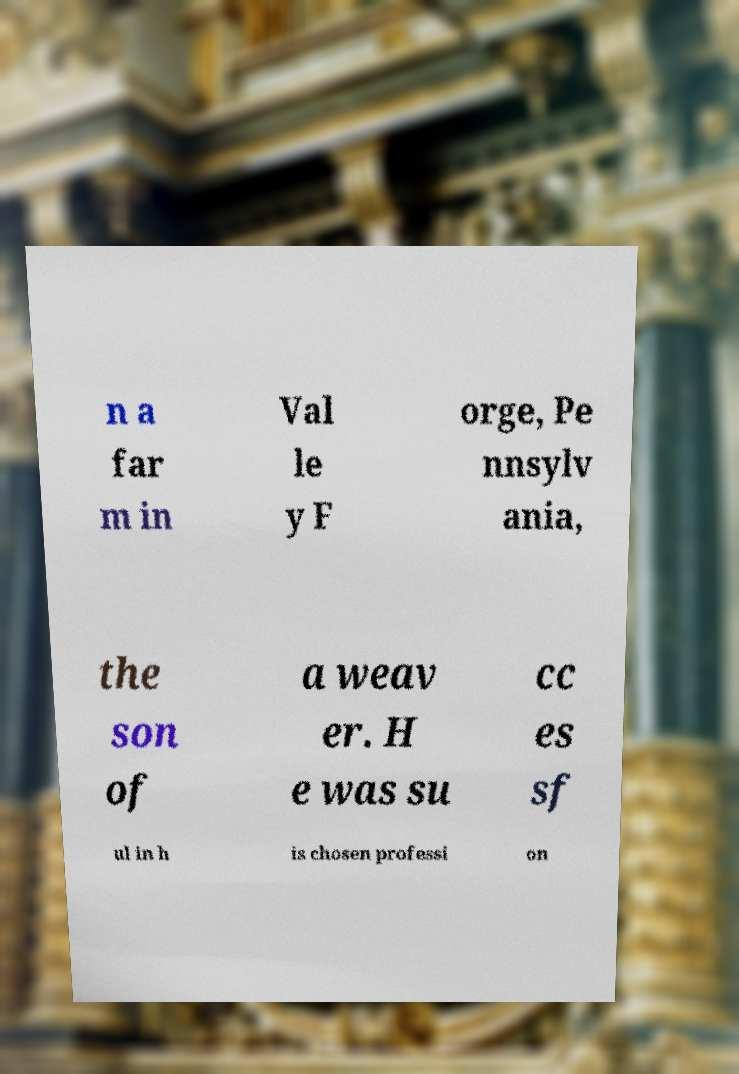I need the written content from this picture converted into text. Can you do that? n a far m in Val le y F orge, Pe nnsylv ania, the son of a weav er. H e was su cc es sf ul in h is chosen professi on 